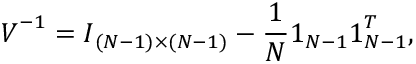<formula> <loc_0><loc_0><loc_500><loc_500>V ^ { - 1 } = I _ { ( N - 1 ) \times ( N - 1 ) } - \frac { 1 } { N } 1 _ { N - 1 } 1 _ { N - 1 } ^ { T } ,</formula> 